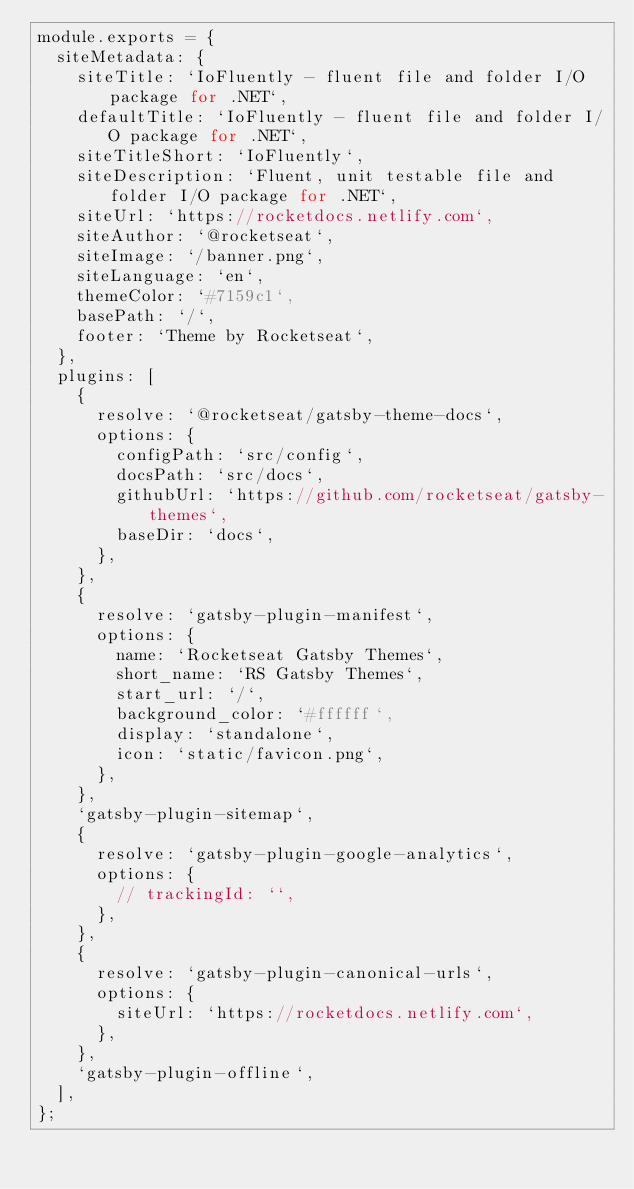Convert code to text. <code><loc_0><loc_0><loc_500><loc_500><_JavaScript_>module.exports = {
  siteMetadata: {
    siteTitle: `IoFluently - fluent file and folder I/O package for .NET`,
    defaultTitle: `IoFluently - fluent file and folder I/O package for .NET`,
    siteTitleShort: `IoFluently`,
    siteDescription: `Fluent, unit testable file and folder I/O package for .NET`,
    siteUrl: `https://rocketdocs.netlify.com`,
    siteAuthor: `@rocketseat`,
    siteImage: `/banner.png`,
    siteLanguage: `en`,
    themeColor: `#7159c1`,
    basePath: `/`,
    footer: `Theme by Rocketseat`,
  },
  plugins: [
    {
      resolve: `@rocketseat/gatsby-theme-docs`,
      options: {
        configPath: `src/config`,
        docsPath: `src/docs`,
        githubUrl: `https://github.com/rocketseat/gatsby-themes`,
        baseDir: `docs`,
      },
    },
    {
      resolve: `gatsby-plugin-manifest`,
      options: {
        name: `Rocketseat Gatsby Themes`,
        short_name: `RS Gatsby Themes`,
        start_url: `/`,
        background_color: `#ffffff`,
        display: `standalone`,
        icon: `static/favicon.png`,
      },
    },
    `gatsby-plugin-sitemap`,
    {
      resolve: `gatsby-plugin-google-analytics`,
      options: {
        // trackingId: ``,
      },
    },
    {
      resolve: `gatsby-plugin-canonical-urls`,
      options: {
        siteUrl: `https://rocketdocs.netlify.com`,
      },
    },
    `gatsby-plugin-offline`,
  ],
};
</code> 